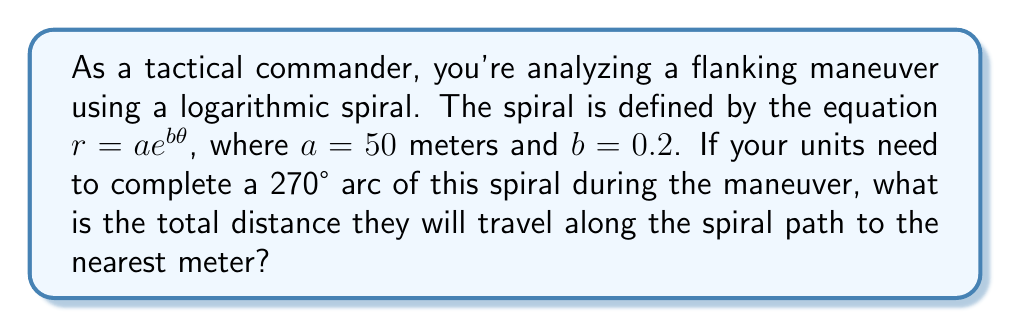Can you answer this question? To solve this problem, we need to calculate the arc length of the logarithmic spiral. The formula for the arc length of a logarithmic spiral from $\theta = 0$ to $\theta = \theta_1$ is:

$$S = \frac{a}{b}\sqrt{1+b^2}(e^{b\theta_1} - 1)$$

Let's break this down step-by-step:

1) We're given $a = 50$ meters, $b = 0.2$, and $\theta_1 = 270° = \frac{3\pi}{2}$ radians.

2) Substituting these values into the formula:

   $$S = \frac{50}{0.2}\sqrt{1+0.2^2}(e^{0.2 \cdot \frac{3\pi}{2}} - 1)$$

3) Simplify the square root:
   $\sqrt{1+0.2^2} = \sqrt{1.04} \approx 1.0198$

4) Calculate $e^{0.2 \cdot \frac{3\pi}{2}}$:
   $e^{0.2 \cdot \frac{3\pi}{2}} \approx 2.5582$

5) Now our equation looks like:
   $$S = 250 \cdot 1.0198 \cdot (2.5582 - 1)$$

6) Simplify:
   $$S = 250 \cdot 1.0198 \cdot 1.5582 \approx 397.4$$

7) Rounding to the nearest meter:
   $$S \approx 397 \text{ meters}$$
Answer: 397 meters 